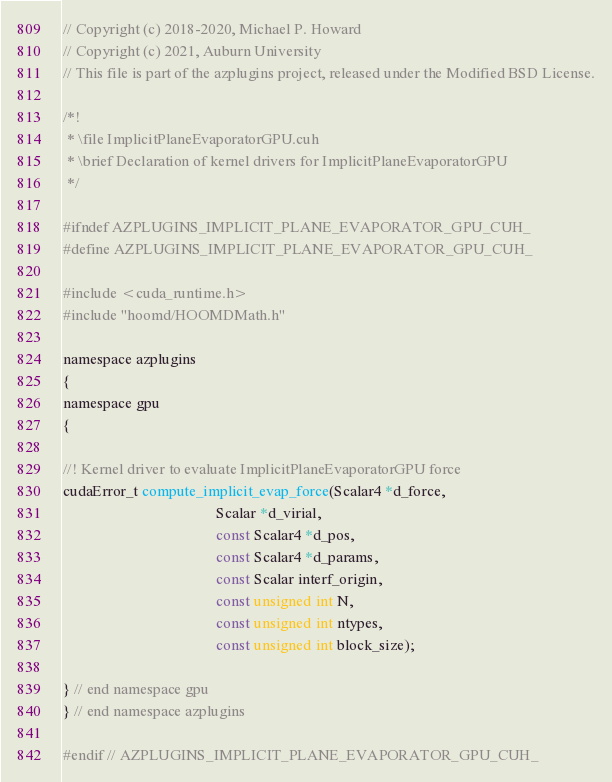<code> <loc_0><loc_0><loc_500><loc_500><_Cuda_>// Copyright (c) 2018-2020, Michael P. Howard
// Copyright (c) 2021, Auburn University
// This file is part of the azplugins project, released under the Modified BSD License.

/*!
 * \file ImplicitPlaneEvaporatorGPU.cuh
 * \brief Declaration of kernel drivers for ImplicitPlaneEvaporatorGPU
 */

#ifndef AZPLUGINS_IMPLICIT_PLANE_EVAPORATOR_GPU_CUH_
#define AZPLUGINS_IMPLICIT_PLANE_EVAPORATOR_GPU_CUH_

#include <cuda_runtime.h>
#include "hoomd/HOOMDMath.h"

namespace azplugins
{
namespace gpu
{

//! Kernel driver to evaluate ImplicitPlaneEvaporatorGPU force
cudaError_t compute_implicit_evap_force(Scalar4 *d_force,
                                        Scalar *d_virial,
                                        const Scalar4 *d_pos,
                                        const Scalar4 *d_params,
                                        const Scalar interf_origin,
                                        const unsigned int N,
                                        const unsigned int ntypes,
                                        const unsigned int block_size);

} // end namespace gpu
} // end namespace azplugins

#endif // AZPLUGINS_IMPLICIT_PLANE_EVAPORATOR_GPU_CUH_
</code> 